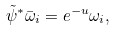Convert formula to latex. <formula><loc_0><loc_0><loc_500><loc_500>\tilde { \psi } ^ { * } \bar { \omega } _ { i } = e ^ { - u } \omega _ { i } ,</formula> 